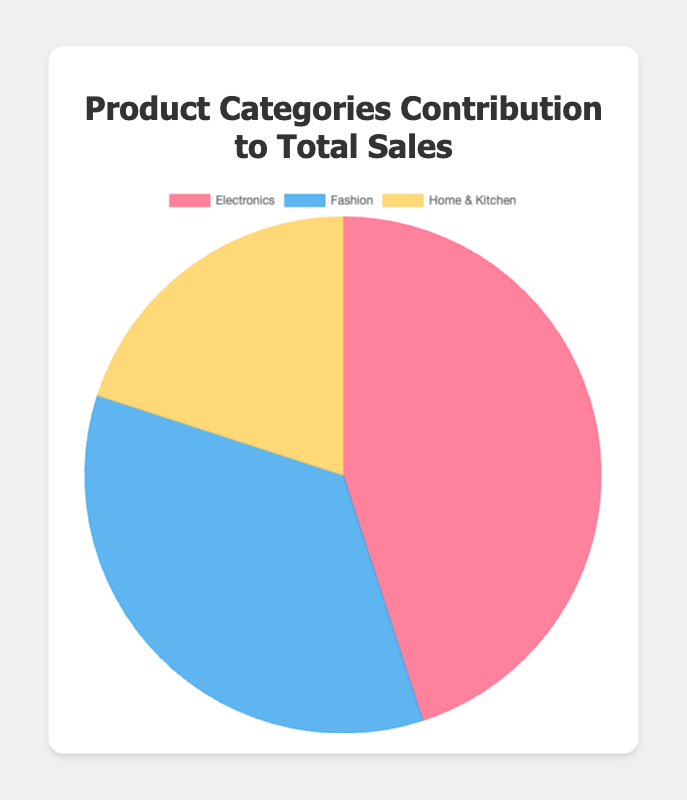What is the category with the highest contribution to total sales? From the pie chart, identify the segment with the largest area. The largest segment indicates the highest percentage contribution. In this case, it is the segment labeled "Electronics," which accounts for 45%.
Answer: Electronics Which product category contributes the least to total sales? From the pie chart, find the segment with the smallest area. The smallest segment indicates the lowest percentage contribution. This is the "Home & Kitchen" segment, which contributes 20%.
Answer: Home & Kitchen By how much does the Electronics category exceed the Fashion category in terms of sales contribution? Subtract the percentage contribution of the Fashion category from that of the Electronics category. Electronics contribute 45% and Fashion 35%, so the difference is 45% - 35% = 10%.
Answer: 10% What is the combined contribution of Fashion and Home & Kitchen categories to total sales? Add the percentage contributions of the Fashion and Home & Kitchen categories. Fashion contributes 35% and Home & Kitchen 20%, so their combined contribution is 35% + 20% = 55%.
Answer: 55% If we wanted to visualize equal sales contribution among categories, by what percentage would the Fashion category need to be increased? In an equal distribution among three categories, each would contribute approximately 33.33%. Fashion currently contributes 35%, which is already slightly higher. Therefore, Fashion actually needs to decrease its contribution to reach equality, so no increase is needed.
Answer: 0% How do the contributions of Electronics and Home & Kitchen compare visually in terms of color? From the pie chart, describe the colors representing each segment. Electronics is represented by the color red and Home & Kitchen by yellow. The red segment is notably larger and more prominent than the yellow one.
Answer: Electronics: Red, Home & Kitchen: Yellow Which two categories combined contribute most closely to the total contribution of Electronics? Sum the contributions of the other two categories and compare them to the contribution of Electronics. Fashion and Home & Kitchen contribute 35% and 20% respectively, totaling 55%, which is closer to Electronics' 45% compared to other possible pairings.
Answer: Fashion and Home & Kitchen What percentage of total sales do the non-Electronics categories contribute together? Add the percentage contributions of the Fashion and Home & Kitchen categories to get the combined contribution. Fashion contributes 35% and Home & Kitchen 20%, so combined this is 35% + 20% = 55%.
Answer: 55% 